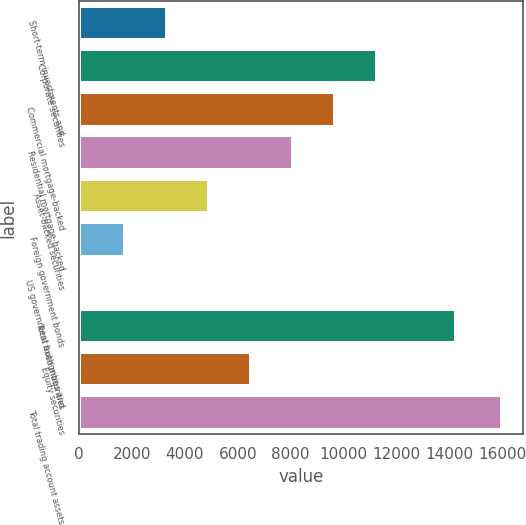<chart> <loc_0><loc_0><loc_500><loc_500><bar_chart><fcel>Short-term investments and<fcel>Corporate securities<fcel>Commercial mortgage-backed<fcel>Residential mortgage-backed<fcel>Asset-backed securities<fcel>Foreign government bonds<fcel>US government authorities and<fcel>Total fixed maturities<fcel>Equity securities<fcel>Total trading account assets<nl><fcel>3333.6<fcel>11245.1<fcel>9662.8<fcel>8080.5<fcel>4915.9<fcel>1751.3<fcel>169<fcel>14234<fcel>6498.2<fcel>15992<nl></chart> 